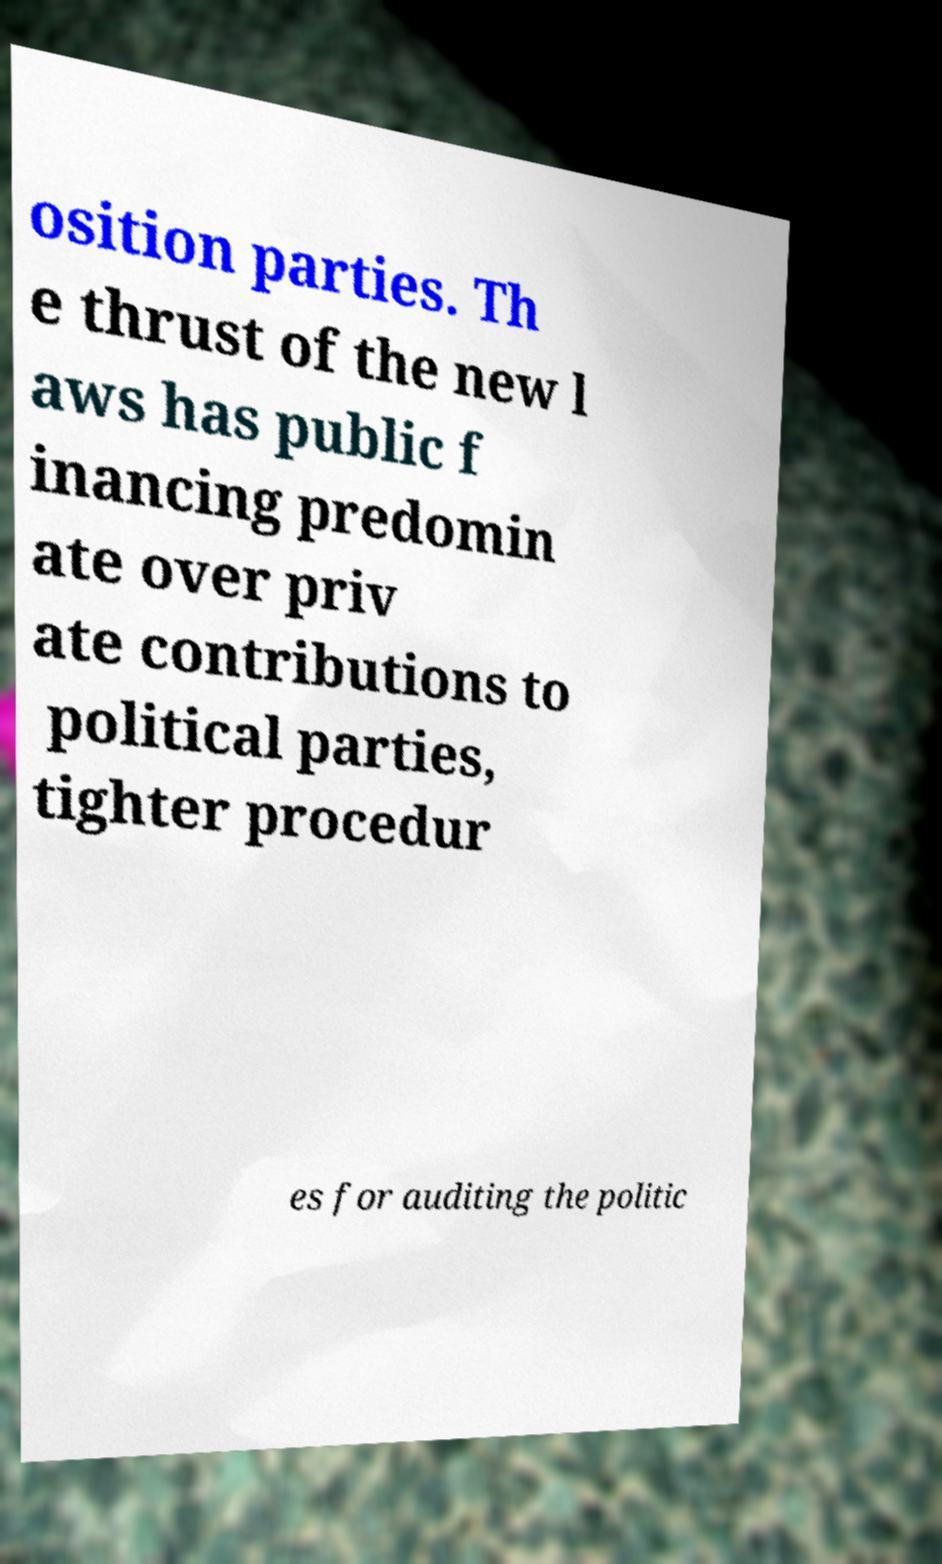Please read and relay the text visible in this image. What does it say? osition parties. Th e thrust of the new l aws has public f inancing predomin ate over priv ate contributions to political parties, tighter procedur es for auditing the politic 